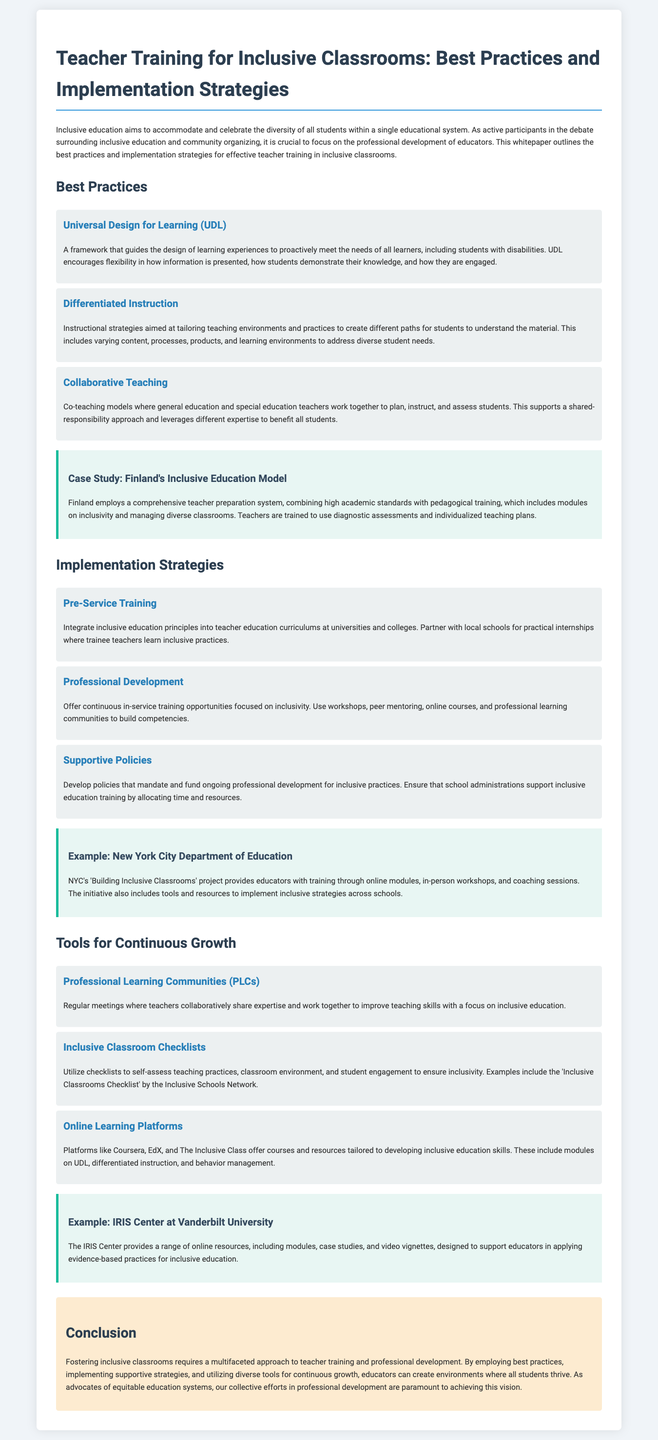What is the main focus of this whitepaper? The whitepaper outlines best practices and implementation strategies for effective teacher training in inclusive classrooms.
Answer: Teacher training for inclusive classrooms What framework encourages flexibility in learning experiences? The document mentions a framework that guides the design of learning experiences, which is known for its flexibility.
Answer: Universal Design for Learning (UDL) What is the case study highlighted in the document? The case study presented in the document discusses a specific country's model for inclusive education.
Answer: Finland's Inclusive Education Model What training opportunity is integrated into teacher education curriculums? The document states that a certain principle is integrated into teacher education curriculums for better inclusivity.
Answer: Inclusive education principles Which project provides training to educators in New York City? The document refers to a specific project designed to enhance educator's skills in inclusive practices in New York City.
Answer: Building Inclusive Classrooms What tool helps teachers collaboratively improve their skills? The document identifies a type of meeting where teachers improve their teaching skills with a focus on inclusivity.
Answer: Professional Learning Communities (PLCs) What type of checklists are mentioned for self-assessment? The document includes a specific type of checklist used by educators to evaluate teaching practices and ensure inclusivity.
Answer: Inclusive Classroom Checklists What conclusion is drawn regarding teacher training approaches? The conclusion emphasizes a specific perspective on the approach to teacher training and professional development.
Answer: Multifaceted approach What educational resource does the IRIS Center provide? This document states that a center provides a range of online resources to support educators.
Answer: Online resources 